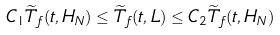<formula> <loc_0><loc_0><loc_500><loc_500>C _ { 1 } \widetilde { T } _ { f } ( t , H _ { N } ) \leq \widetilde { T } _ { f } ( t , L ) \leq C _ { 2 } \widetilde { T } _ { f } ( t , H _ { N } )</formula> 